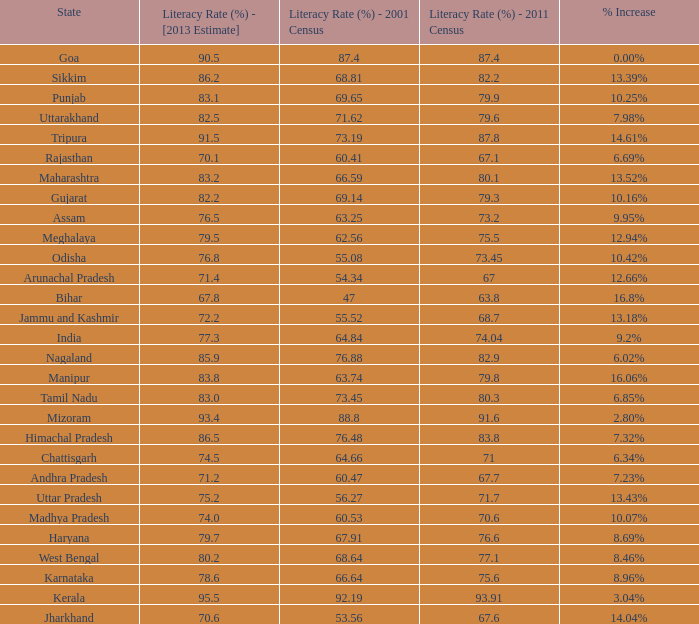What is the average increase in literacy for the states that had a rate higher than 73.2% in 2011, less than 68.81% in 2001, and an estimate of 76.8% for 2013? 10.42%. 